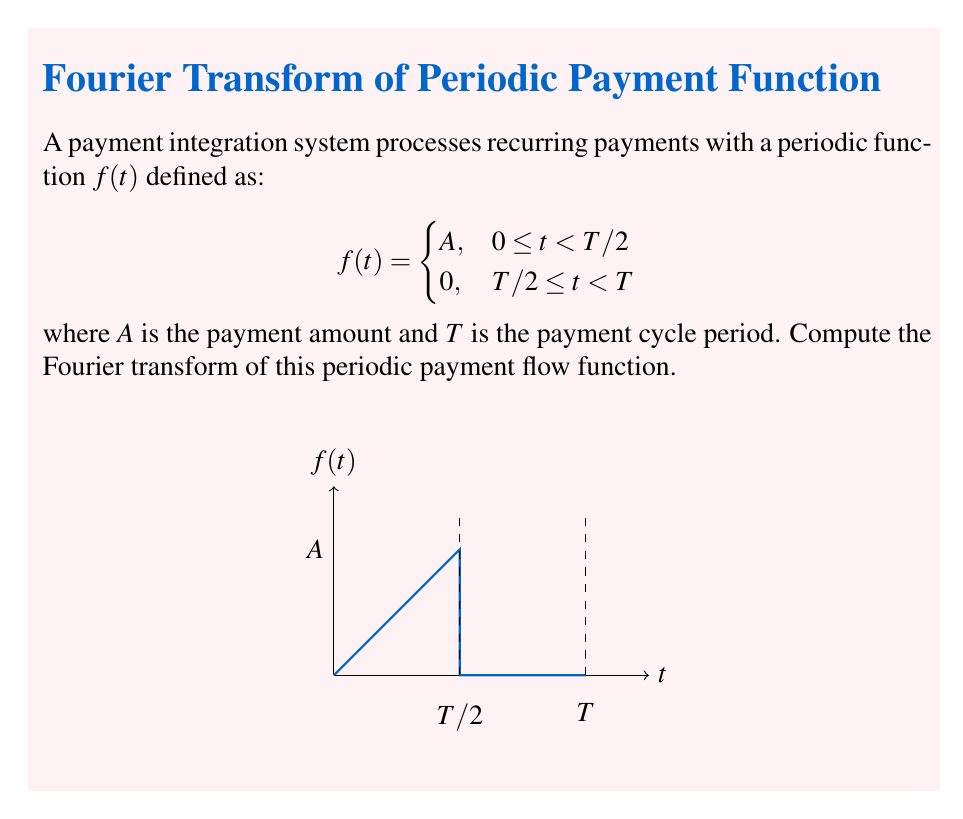Teach me how to tackle this problem. To compute the Fourier transform of the periodic payment flow function, we'll follow these steps:

1) The Fourier transform of a periodic function is a series of delta functions at multiples of the fundamental frequency $\omega_0 = \frac{2\pi}{T}$. The coefficients of these delta functions are given by the Fourier series coefficients multiplied by the period $T$.

2) First, let's compute the Fourier series coefficients $c_n$:

   $$c_n = \frac{1}{T} \int_0^T f(t) e^{-i n \omega_0 t} dt$$

3) Split the integral into two parts:

   $$c_n = \frac{1}{T} \left(\int_0^{T/2} A e^{-i n \omega_0 t} dt + \int_{T/2}^T 0 \cdot e^{-i n \omega_0 t} dt\right)$$

4) Evaluate the non-zero part:

   $$c_n = \frac{A}{T} \int_0^{T/2} e^{-i n \omega_0 t} dt = \frac{A}{T} \left[\frac{-1}{in\omega_0} e^{-i n \omega_0 t}\right]_0^{T/2}$$

5) Substitute the limits:

   $$c_n = \frac{A}{T} \cdot \frac{-1}{in\omega_0} (e^{-i n \pi} - 1) = \frac{A}{in\omega_0} (1 - e^{-i n \pi})$$

6) Simplify using Euler's formula:

   $$c_n = \frac{A}{in\omega_0} (1 - \cos(n\pi) + i\sin(n\pi)) = \frac{A}{n\pi} (\sin(n\pi) + i(1-\cos(n\pi)))$$

7) The Fourier transform $F(\omega)$ is given by:

   $$F(\omega) = T \sum_{n=-\infty}^{\infty} c_n \delta(\omega - n\omega_0)$$

8) Substitute the expression for $c_n$:

   $$F(\omega) = \frac{AT}{\pi} \sum_{n=-\infty}^{\infty} \frac{1}{n} (\sin(n\pi) + i(1-\cos(n\pi))) \delta(\omega - n\omega_0)$$

This is the Fourier transform of the periodic payment flow function.
Answer: $$F(\omega) = \frac{AT}{\pi} \sum_{n=-\infty}^{\infty} \frac{1}{n} (\sin(n\pi) + i(1-\cos(n\pi))) \delta(\omega - n\omega_0)$$ 